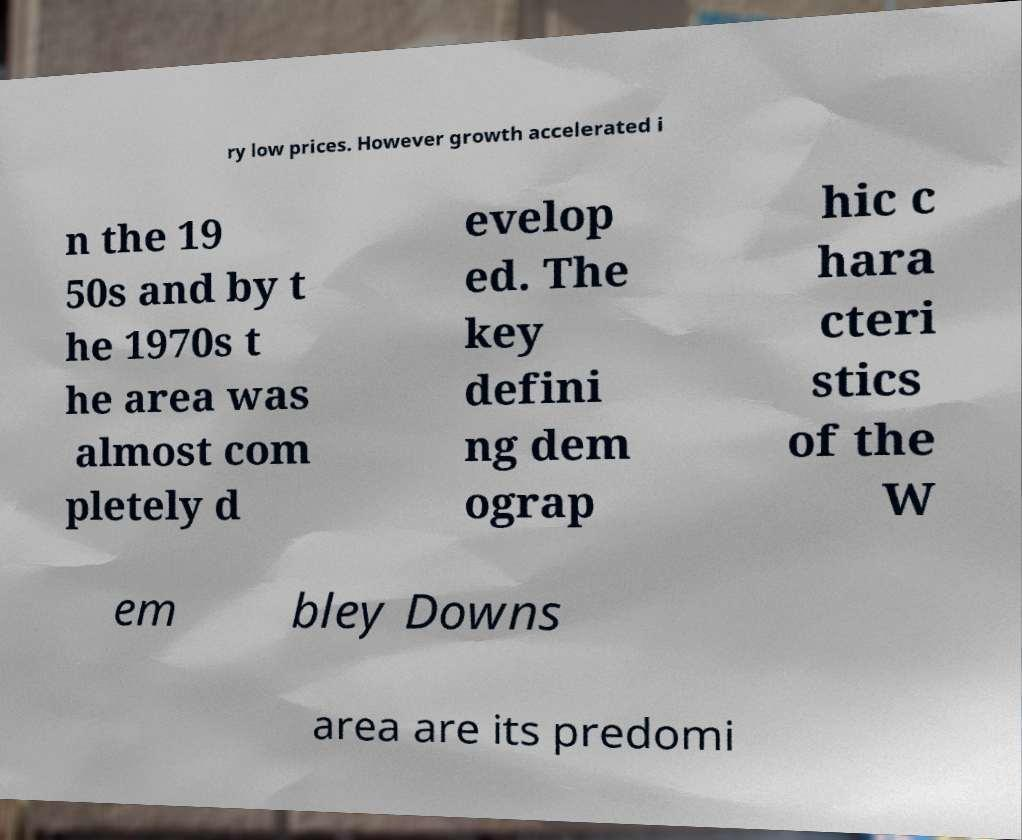What messages or text are displayed in this image? I need them in a readable, typed format. ry low prices. However growth accelerated i n the 19 50s and by t he 1970s t he area was almost com pletely d evelop ed. The key defini ng dem ograp hic c hara cteri stics of the W em bley Downs area are its predomi 